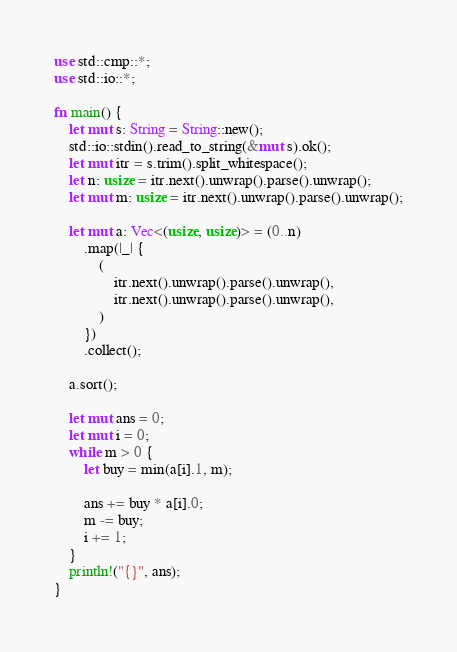<code> <loc_0><loc_0><loc_500><loc_500><_Rust_>use std::cmp::*;
use std::io::*;

fn main() {
    let mut s: String = String::new();
    std::io::stdin().read_to_string(&mut s).ok();
    let mut itr = s.trim().split_whitespace();
    let n: usize = itr.next().unwrap().parse().unwrap();
    let mut m: usize = itr.next().unwrap().parse().unwrap();

    let mut a: Vec<(usize, usize)> = (0..n)
        .map(|_| {
            (
                itr.next().unwrap().parse().unwrap(),
                itr.next().unwrap().parse().unwrap(),
            )
        })
        .collect();

    a.sort();

    let mut ans = 0;
    let mut i = 0;
    while m > 0 {
        let buy = min(a[i].1, m);

        ans += buy * a[i].0;
        m -= buy;
        i += 1;
    }
    println!("{}", ans);
}</code> 